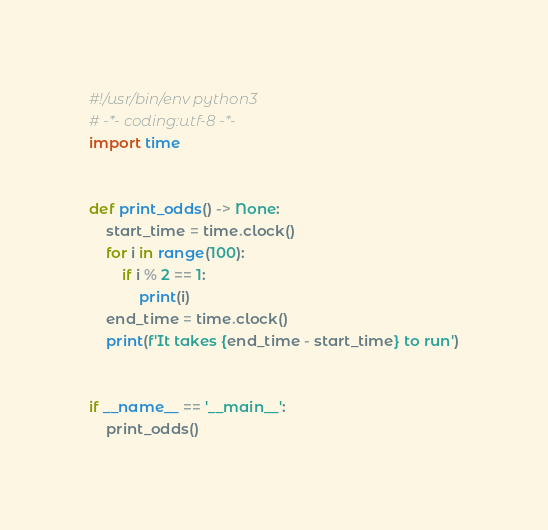Convert code to text. <code><loc_0><loc_0><loc_500><loc_500><_Python_>#!/usr/bin/env python3
# -*- coding:utf-8 -*-
import time


def print_odds() -> None:
    start_time = time.clock()
    for i in range(100):
        if i % 2 == 1:
            print(i)
    end_time = time.clock()
    print(f'It takes {end_time - start_time} to run')


if __name__ == '__main__':
    print_odds()

</code> 